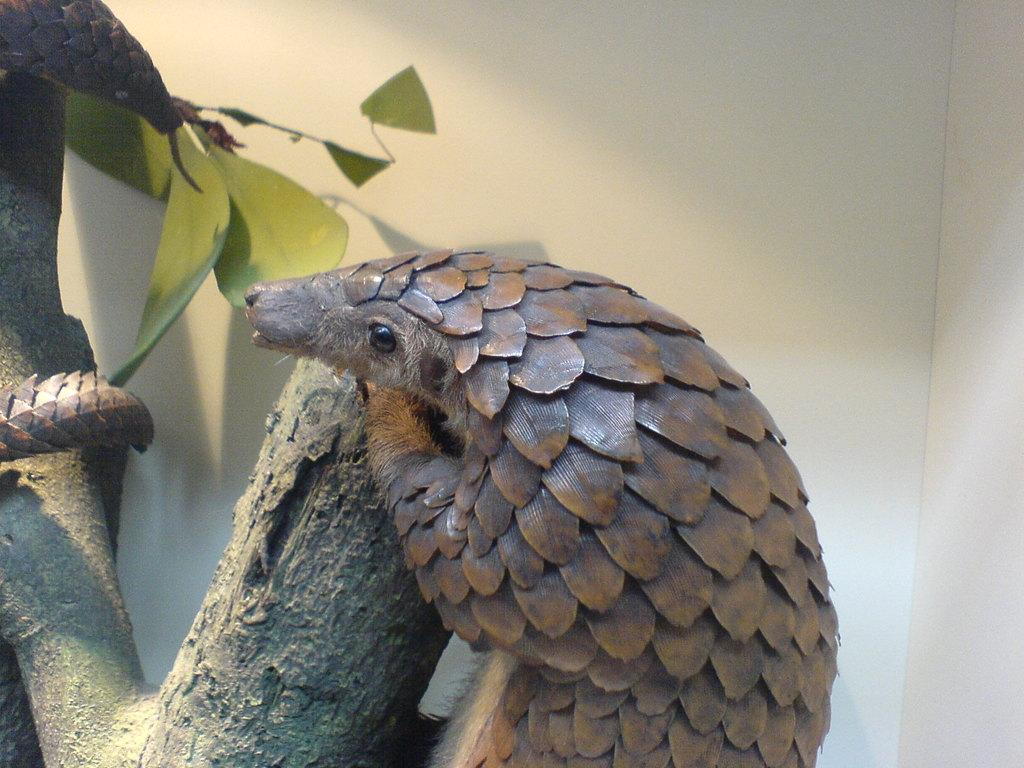What type of creature can be seen in the image? There is an animal or bird in the image. What color is the creature? The animal or bird is brown in color. Where is the creature located in the image? The creature is on a tree. What can be seen in the background of the image? There is a white wall in the background of the image. How does the creature start the engine of a car in the image? The creature does not start an engine in the image; it is on a tree. What type of bears can be seen in the image? There are no bears present in the image. 